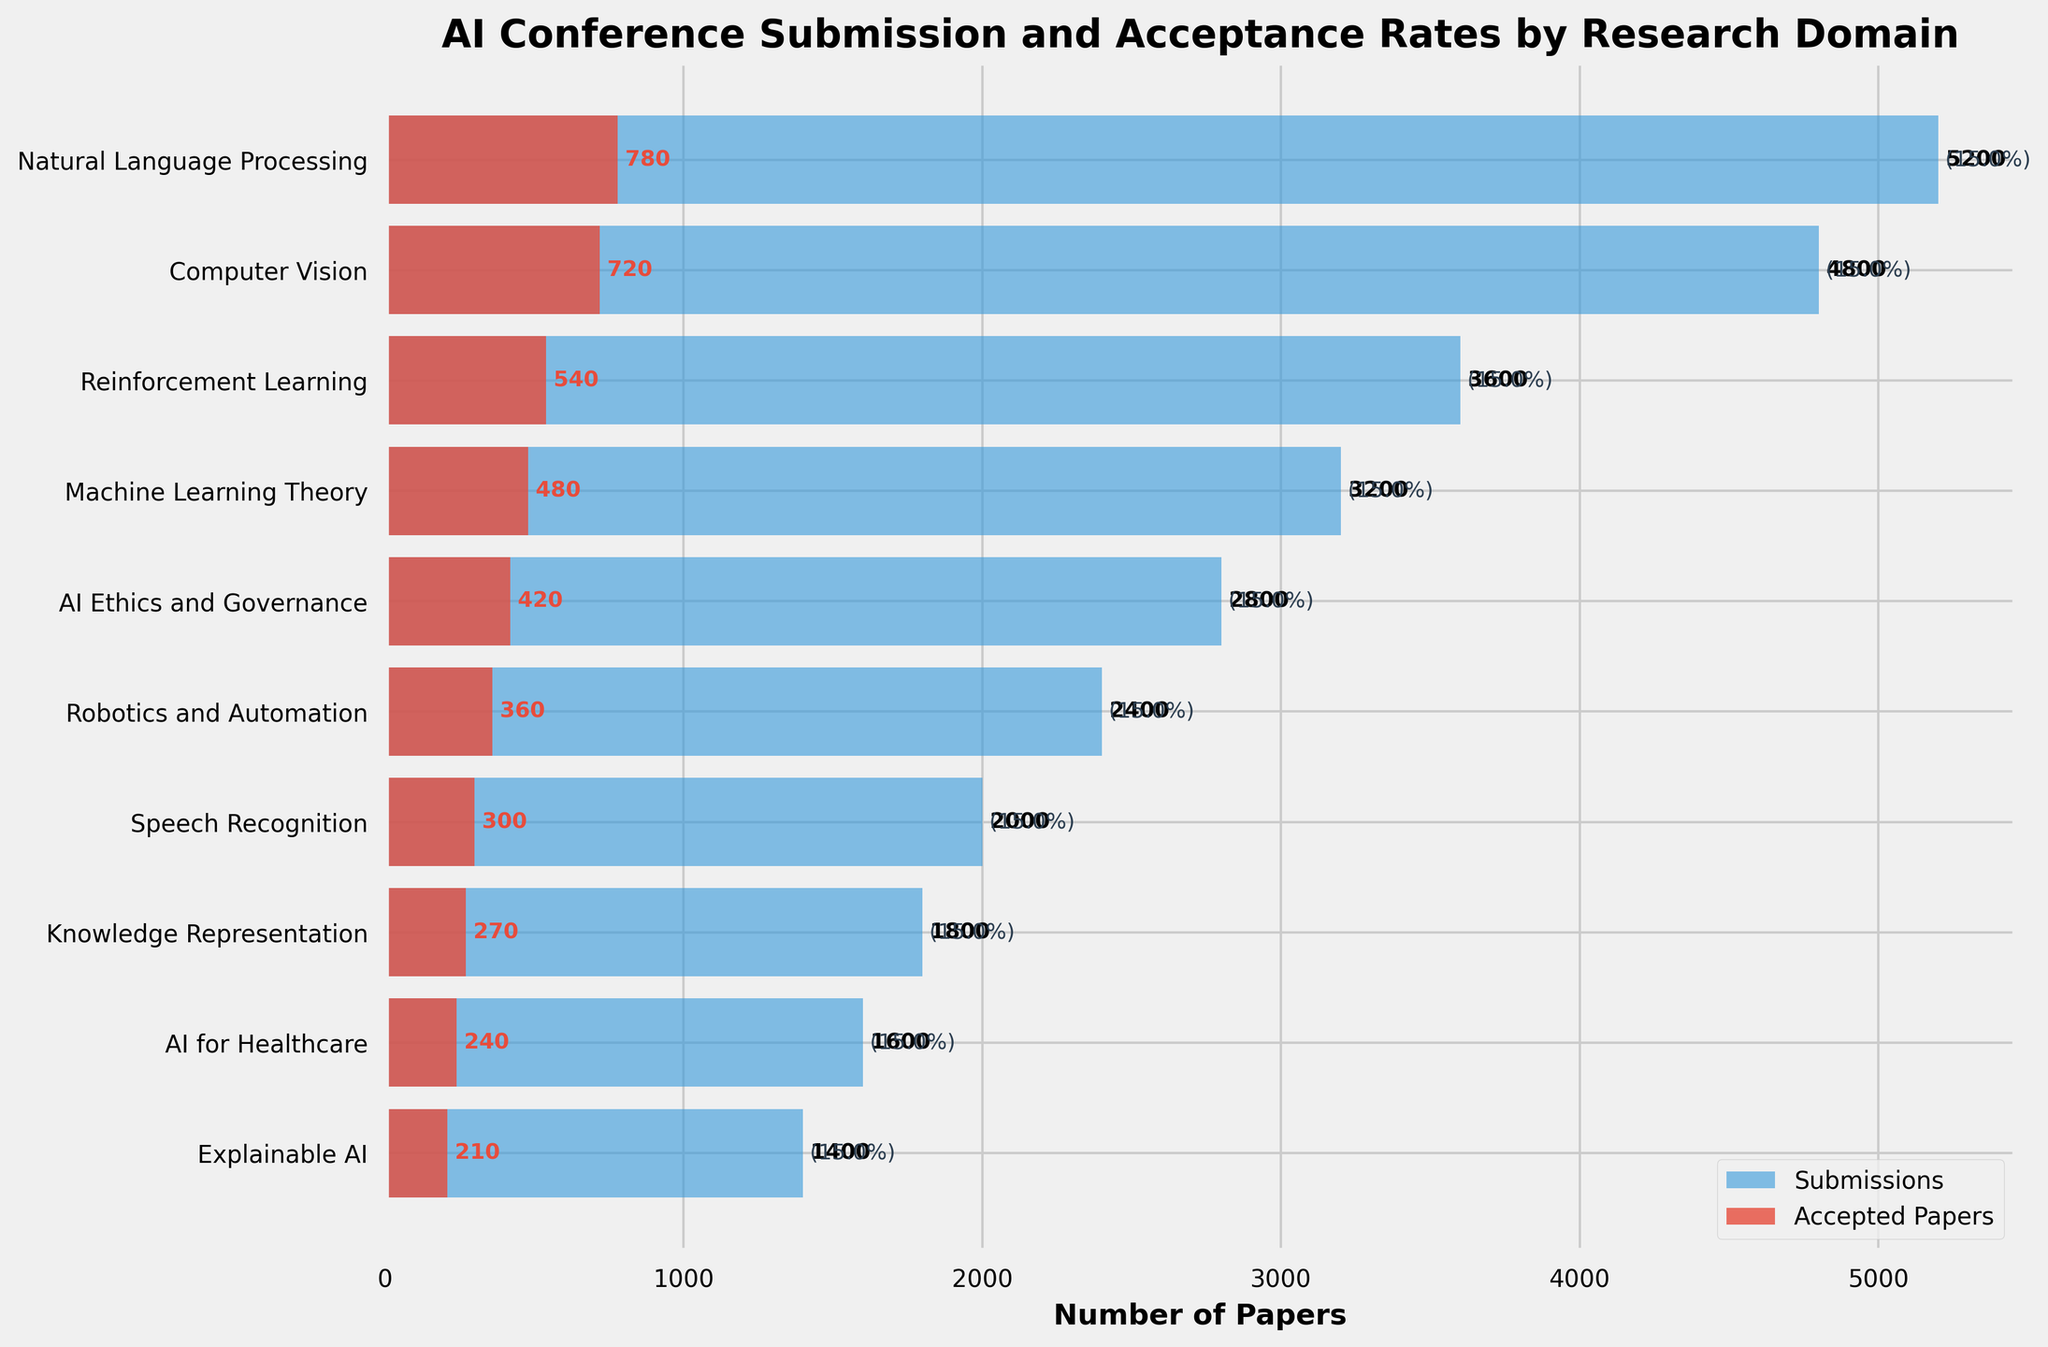What is the title of the chart? The title of the chart is placed at the top and is usually designed to give an overview of the chart's content. The title in this chart is "AI Conference Submission and Acceptance Rates by Research Domain".
Answer: AI Conference Submission and Acceptance Rates by Research Domain Which research domain has the highest number of submissions? By looking at the horizontal bars representing submissions for each research domain, the longest bar indicates the highest number of submissions. The domain with the longest bar shows 5200 submissions for Natural Language Processing.
Answer: Natural Language Processing What is the acceptance rate for the Reinforcement Learning domain? The acceptance rate is calculated as (Accepted Papers / Submissions) * 100. For Reinforcement Learning, there are 540 accepted papers and 3600 submissions. So, the acceptance rate is (540/3600) * 100 = 15%.
Answer: 15% How many more submissions did Computer Vision have compared to AI for Healthcare? Subtract the number of submissions for AI for Healthcare (1600) from Computer Vision (4800). Thus, 4800 - 1600 = 3200.
Answer: 3200 Which domain has the smallest difference between submissions and accepted papers? By examining the lengths of the bars for submissions and accepted papers, the smallest gap visually indicates the smallest difference. Calculating the difference for each domain, Natural Language Processing has 5200 - 780 = 4420, Computer Vision has 4800 - 720 = 4080, and AI Ethics and Governance has the smallest difference with 2800 - 420 = 2380.
Answer: AI Ethics and Governance What is the overall acceptance rate for all domains combined? First, find the total submissions and accepted papers across all domains, then calculate the acceptance rate. Total submissions = 5200 + 4800 + 3600 + 3200 + 2800 + 2400 + 2000 + 1800 + 1600 + 1400 = 28800. Total accepted papers = 780 + 720 + 540 + 480 + 420 + 360 + 300 + 270 + 240 + 210 = 4320. The acceptance rate is (4320 / 28800) * 100 ≈ 15%.
Answer: 15% Which domain has a higher acceptance rate, Robotics and Automation or Explainable AI? Calculate the acceptance rate for both domains. Robotics and Automation: (360/2400) * 100 = 15%. Explainable AI: (210/1400) * 100 = 15%.
Answer: They have the same acceptance rate (15%) Rank the domains by their acceptance rates from highest to lowest. Calculate the acceptance rate for each domain and then rank them in descending order. Natural Language Processing: 15%, Computer Vision: 15%, Reinforcement Learning: 15%, Machine Learning Theory: 15%, AI Ethics and Governance: 15%, Robotics and Automation: 15%, Speech Recognition: 15%, Knowledge Representation: 15%, AI for Healthcare: 15%, Explainable AI: 15%. As all domains have the same acceptance rate, the ranking is arbitrary.
Answer: All domains have the same acceptance rate (15%) 